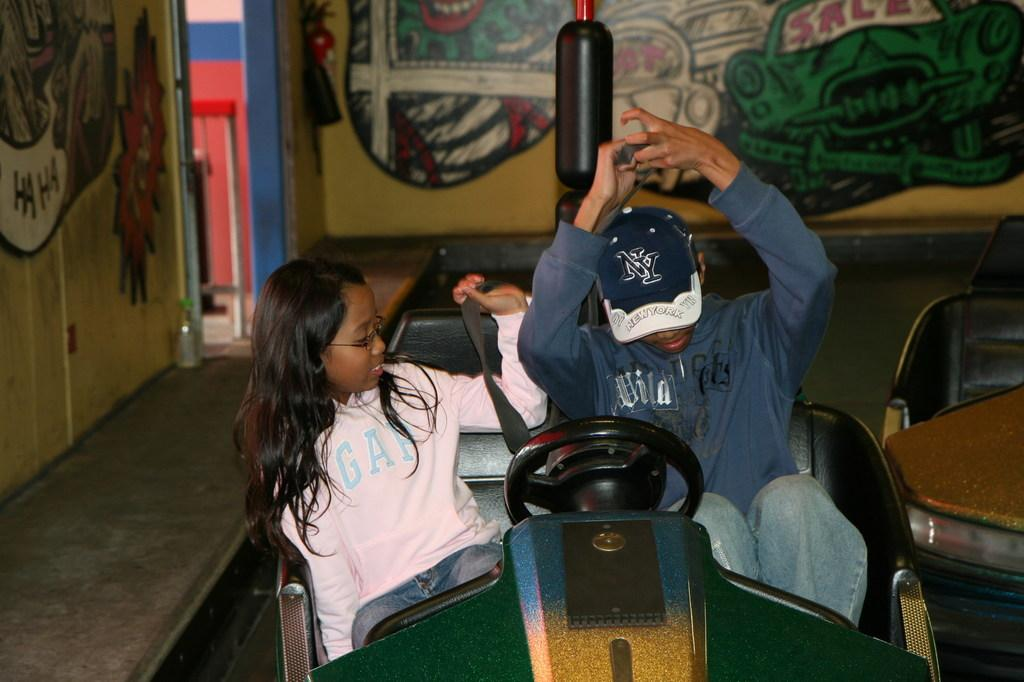Provide a one-sentence caption for the provided image. A man, sitting next to a girl, wears a hat with the initials NY. 